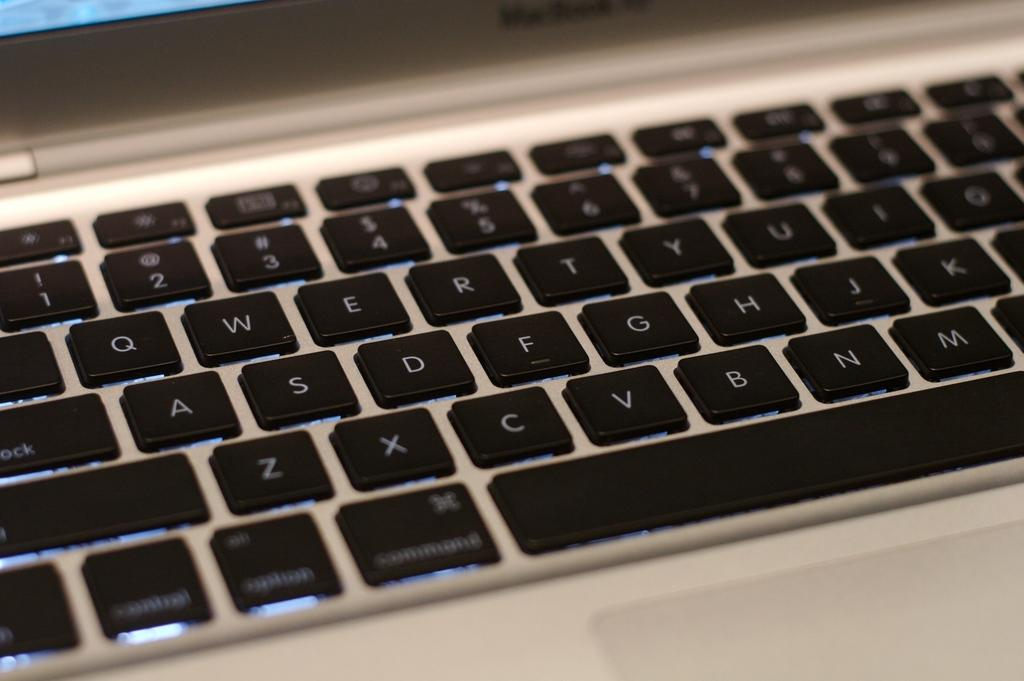<image>
Describe the image concisely. Computer keyboard with different keys and letters, looks like a mac because I see Command as one of the keys. 